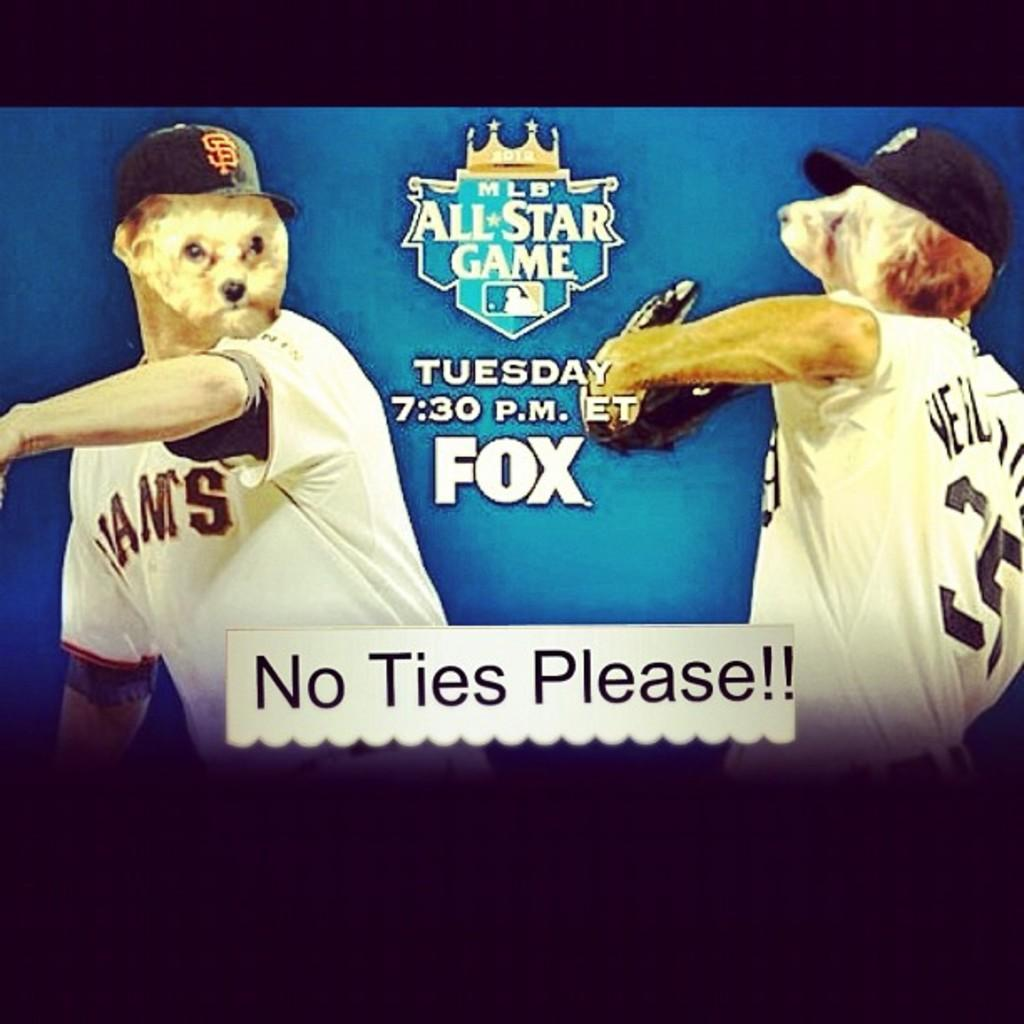Provide a one-sentence caption for the provided image. a world series promo with the word Fox on it. 